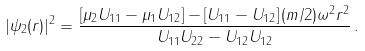<formula> <loc_0><loc_0><loc_500><loc_500>| \psi _ { 2 } ( { r } ) | ^ { 2 } = \frac { \left [ \mu _ { 2 } U _ { 1 1 } - \mu _ { 1 } U _ { 1 2 } \right ] - \left [ U _ { 1 1 } - U _ { 1 2 } \right ] ( m / 2 ) \omega ^ { 2 } r ^ { 2 } } { U _ { 1 1 } U _ { 2 2 } - U _ { 1 2 } U _ { 1 2 } } \, .</formula> 